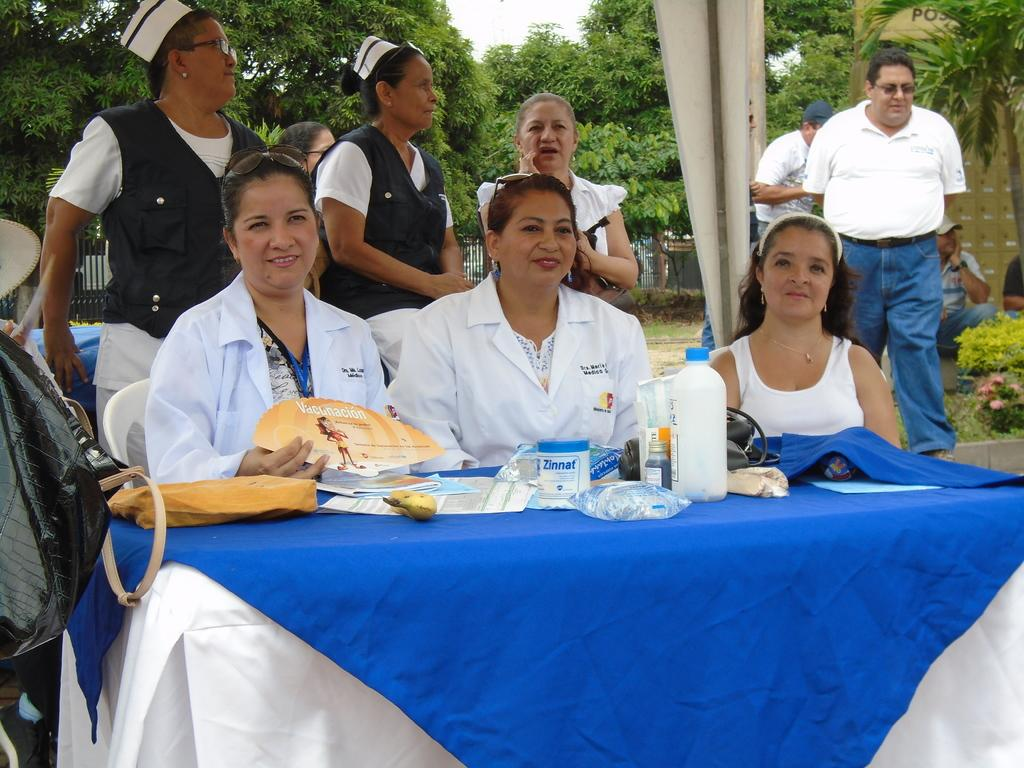How many women are in the image? There are three women in the image. What are the women doing in the image? The women are sitting on chairs. What is in front of the women? There is a table in front of the women. Are there any other people in the image besides the women? Yes, there are people standing behind the women. What can be seen in the background of the image? Trees are visible in the image. How many pairs of shoes can be seen on the kittens in the image? There are no kittens present in the image, so there are no shoes on kittens to count. 